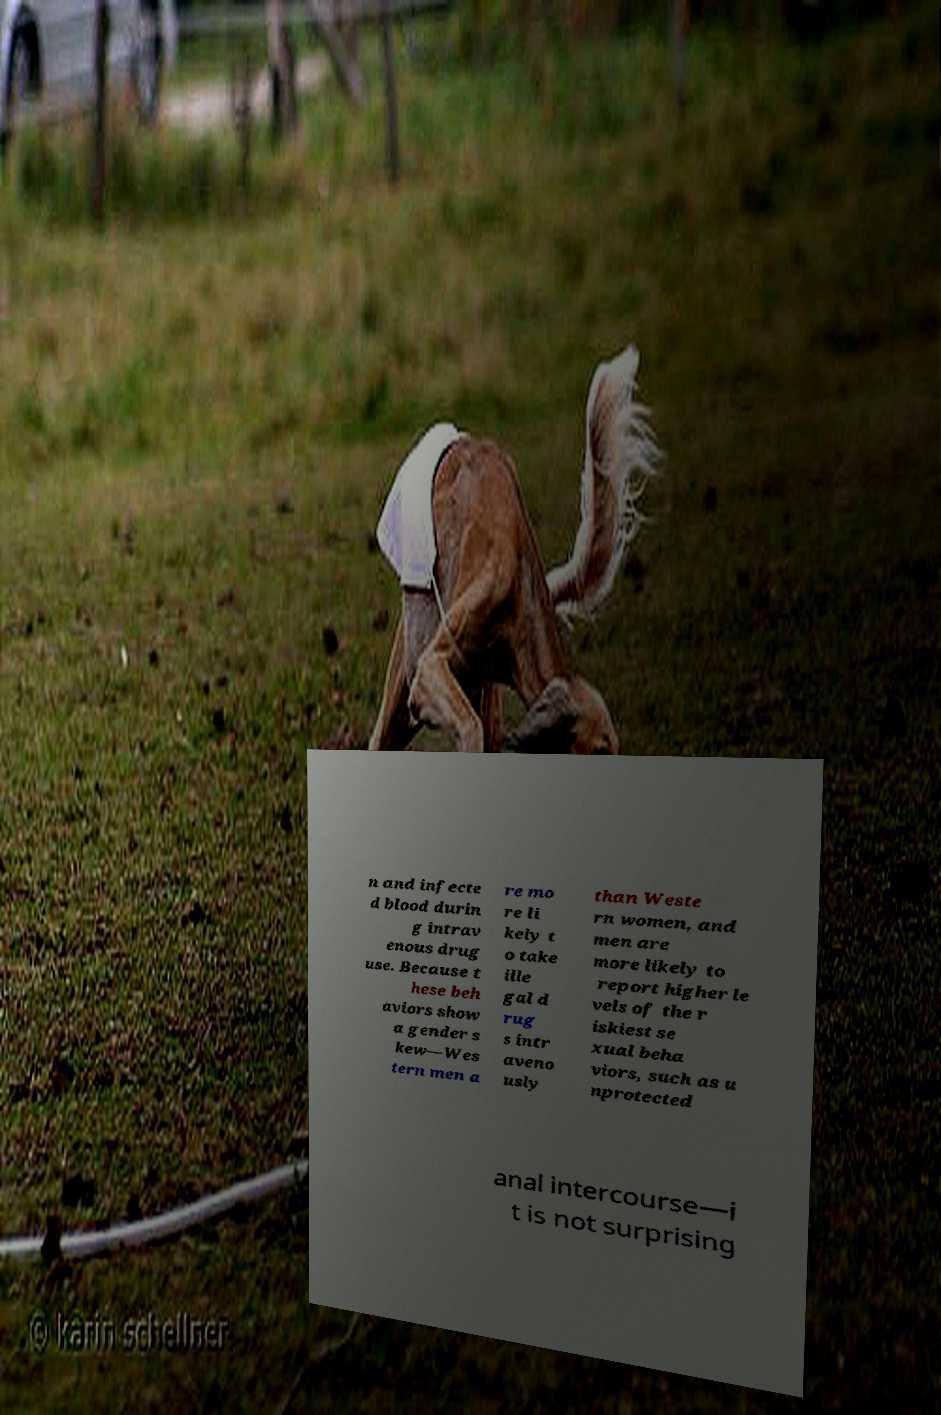For documentation purposes, I need the text within this image transcribed. Could you provide that? n and infecte d blood durin g intrav enous drug use. Because t hese beh aviors show a gender s kew—Wes tern men a re mo re li kely t o take ille gal d rug s intr aveno usly than Weste rn women, and men are more likely to report higher le vels of the r iskiest se xual beha viors, such as u nprotected anal intercourse—i t is not surprising 